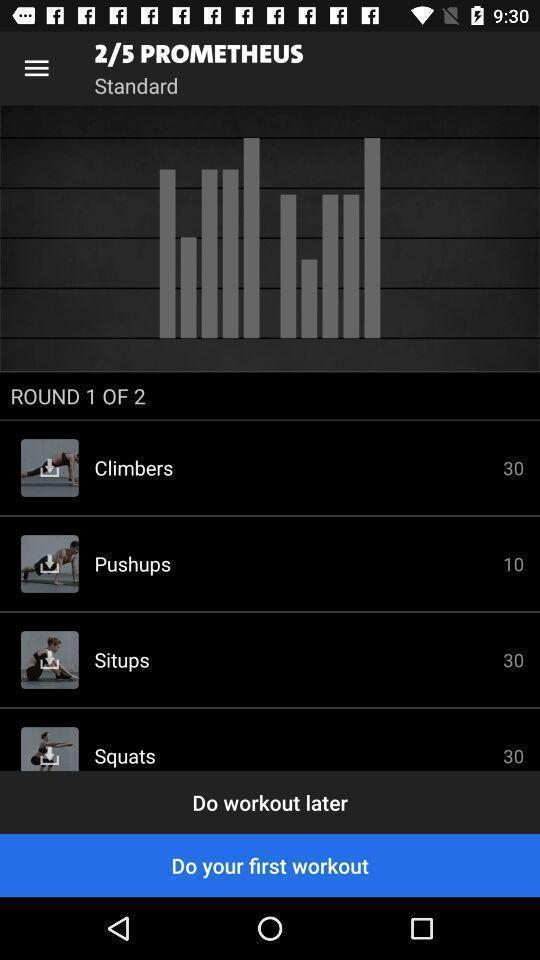Provide a description of this screenshot. Page displaying various workouts in a fitness app. 